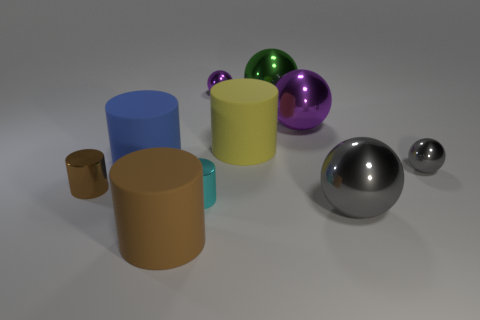How many objects are either big purple shiny objects or small cylinders?
Ensure brevity in your answer.  3. Does the tiny sphere on the right side of the large purple ball have the same color as the metal sphere left of the big yellow matte object?
Your response must be concise. No. How many other objects are there of the same shape as the large gray metallic thing?
Offer a very short reply. 4. Are any big spheres visible?
Keep it short and to the point. Yes. What number of things are big yellow cylinders or objects behind the big green shiny sphere?
Offer a very short reply. 2. Do the rubber object on the left side of the brown matte thing and the tiny gray shiny sphere have the same size?
Offer a terse response. No. How many other objects are there of the same size as the cyan thing?
Your response must be concise. 3. There is a gray ball behind the cyan thing; what is it made of?
Your answer should be compact. Metal. Are there an equal number of metal balls right of the big purple sphere and tiny gray balls?
Your answer should be compact. No. Is the cyan thing the same shape as the blue matte thing?
Provide a short and direct response. Yes. 